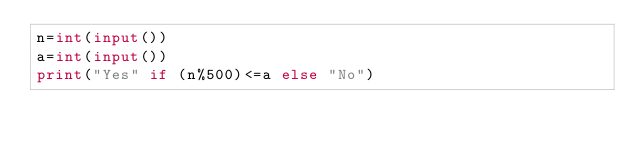Convert code to text. <code><loc_0><loc_0><loc_500><loc_500><_Python_>n=int(input())
a=int(input())
print("Yes" if (n%500)<=a else "No")</code> 